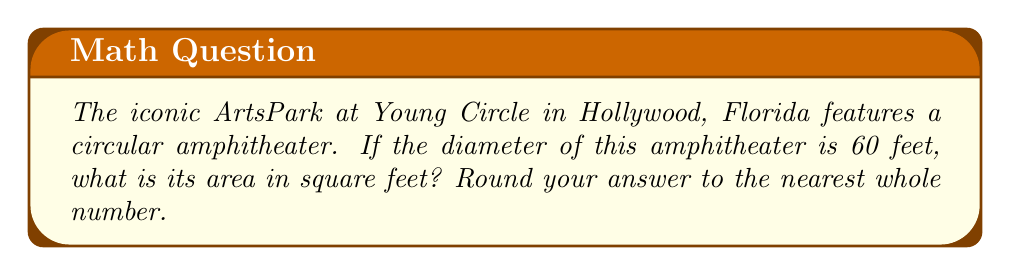Teach me how to tackle this problem. To calculate the area of the circular amphitheater, we'll use the formula for the area of a circle:

$$A = \pi r^2$$

Where:
$A$ = area
$\pi$ = pi (approximately 3.14159)
$r$ = radius

Given:
- The diameter is 60 feet
- The radius is half the diameter

Step 1: Calculate the radius
$$r = \frac{60}{2} = 30\text{ feet}$$

Step 2: Apply the area formula
$$A = \pi (30)^2$$

Step 3: Calculate
$$A = \pi (900)$$
$$A \approx 3.14159 \times 900$$
$$A \approx 2827.43\text{ square feet}$$

Step 4: Round to the nearest whole number
$$A \approx 2827\text{ square feet}$$
Answer: 2827 square feet 